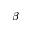Convert formula to latex. <formula><loc_0><loc_0><loc_500><loc_500>\beta</formula> 